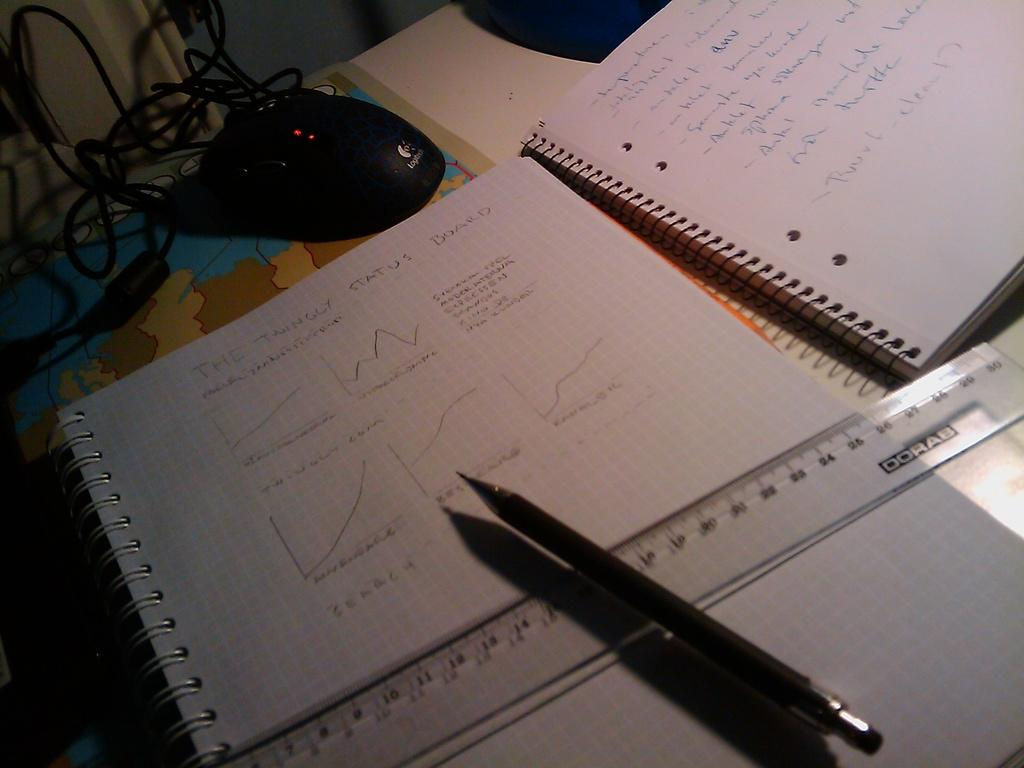<image>
Share a concise interpretation of the image provided. Pen on top of a clear ruler that has the word DORAB on it. 